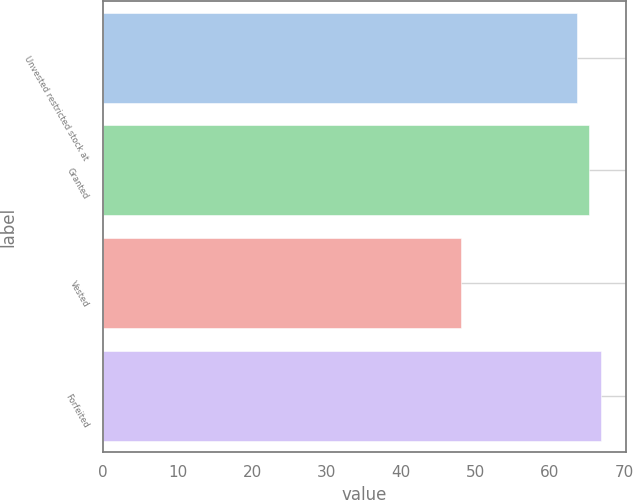Convert chart to OTSL. <chart><loc_0><loc_0><loc_500><loc_500><bar_chart><fcel>Unvested restricted stock at<fcel>Granted<fcel>Vested<fcel>Forfeited<nl><fcel>63.64<fcel>65.28<fcel>48.14<fcel>66.92<nl></chart> 